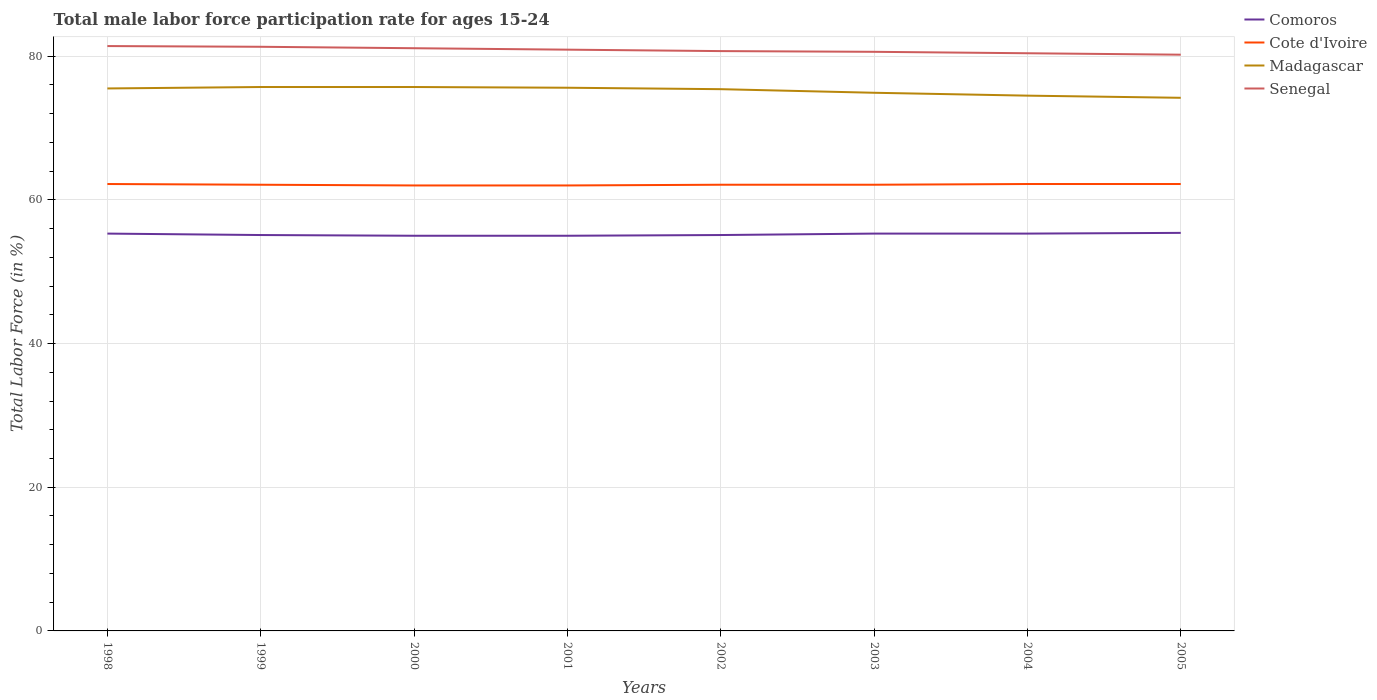Does the line corresponding to Cote d'Ivoire intersect with the line corresponding to Senegal?
Keep it short and to the point. No. Is the number of lines equal to the number of legend labels?
Ensure brevity in your answer.  Yes. Across all years, what is the maximum male labor force participation rate in Senegal?
Offer a terse response. 80.2. What is the total male labor force participation rate in Madagascar in the graph?
Give a very brief answer. 1.4. What is the difference between the highest and the second highest male labor force participation rate in Senegal?
Your response must be concise. 1.2. What is the difference between the highest and the lowest male labor force participation rate in Senegal?
Offer a terse response. 4. Is the male labor force participation rate in Cote d'Ivoire strictly greater than the male labor force participation rate in Comoros over the years?
Give a very brief answer. No. How many lines are there?
Keep it short and to the point. 4. How many years are there in the graph?
Give a very brief answer. 8. What is the difference between two consecutive major ticks on the Y-axis?
Your answer should be compact. 20. How many legend labels are there?
Offer a very short reply. 4. What is the title of the graph?
Give a very brief answer. Total male labor force participation rate for ages 15-24. Does "Namibia" appear as one of the legend labels in the graph?
Make the answer very short. No. What is the label or title of the Y-axis?
Offer a terse response. Total Labor Force (in %). What is the Total Labor Force (in %) of Comoros in 1998?
Offer a terse response. 55.3. What is the Total Labor Force (in %) in Cote d'Ivoire in 1998?
Make the answer very short. 62.2. What is the Total Labor Force (in %) in Madagascar in 1998?
Offer a terse response. 75.5. What is the Total Labor Force (in %) in Senegal in 1998?
Provide a succinct answer. 81.4. What is the Total Labor Force (in %) in Comoros in 1999?
Make the answer very short. 55.1. What is the Total Labor Force (in %) in Cote d'Ivoire in 1999?
Your answer should be compact. 62.1. What is the Total Labor Force (in %) in Madagascar in 1999?
Your answer should be very brief. 75.7. What is the Total Labor Force (in %) in Senegal in 1999?
Your response must be concise. 81.3. What is the Total Labor Force (in %) of Comoros in 2000?
Give a very brief answer. 55. What is the Total Labor Force (in %) of Madagascar in 2000?
Ensure brevity in your answer.  75.7. What is the Total Labor Force (in %) in Senegal in 2000?
Offer a terse response. 81.1. What is the Total Labor Force (in %) in Cote d'Ivoire in 2001?
Give a very brief answer. 62. What is the Total Labor Force (in %) of Madagascar in 2001?
Offer a terse response. 75.6. What is the Total Labor Force (in %) in Senegal in 2001?
Provide a succinct answer. 80.9. What is the Total Labor Force (in %) of Comoros in 2002?
Keep it short and to the point. 55.1. What is the Total Labor Force (in %) of Cote d'Ivoire in 2002?
Provide a short and direct response. 62.1. What is the Total Labor Force (in %) of Madagascar in 2002?
Keep it short and to the point. 75.4. What is the Total Labor Force (in %) in Senegal in 2002?
Ensure brevity in your answer.  80.7. What is the Total Labor Force (in %) in Comoros in 2003?
Your answer should be very brief. 55.3. What is the Total Labor Force (in %) in Cote d'Ivoire in 2003?
Provide a short and direct response. 62.1. What is the Total Labor Force (in %) in Madagascar in 2003?
Offer a very short reply. 74.9. What is the Total Labor Force (in %) in Senegal in 2003?
Offer a very short reply. 80.6. What is the Total Labor Force (in %) in Comoros in 2004?
Keep it short and to the point. 55.3. What is the Total Labor Force (in %) in Cote d'Ivoire in 2004?
Give a very brief answer. 62.2. What is the Total Labor Force (in %) of Madagascar in 2004?
Provide a succinct answer. 74.5. What is the Total Labor Force (in %) in Senegal in 2004?
Give a very brief answer. 80.4. What is the Total Labor Force (in %) in Comoros in 2005?
Give a very brief answer. 55.4. What is the Total Labor Force (in %) of Cote d'Ivoire in 2005?
Your answer should be compact. 62.2. What is the Total Labor Force (in %) in Madagascar in 2005?
Your answer should be compact. 74.2. What is the Total Labor Force (in %) of Senegal in 2005?
Provide a succinct answer. 80.2. Across all years, what is the maximum Total Labor Force (in %) of Comoros?
Your response must be concise. 55.4. Across all years, what is the maximum Total Labor Force (in %) in Cote d'Ivoire?
Your answer should be compact. 62.2. Across all years, what is the maximum Total Labor Force (in %) in Madagascar?
Make the answer very short. 75.7. Across all years, what is the maximum Total Labor Force (in %) in Senegal?
Your response must be concise. 81.4. Across all years, what is the minimum Total Labor Force (in %) of Madagascar?
Your answer should be very brief. 74.2. Across all years, what is the minimum Total Labor Force (in %) of Senegal?
Give a very brief answer. 80.2. What is the total Total Labor Force (in %) of Comoros in the graph?
Your response must be concise. 441.5. What is the total Total Labor Force (in %) of Cote d'Ivoire in the graph?
Give a very brief answer. 496.9. What is the total Total Labor Force (in %) in Madagascar in the graph?
Make the answer very short. 601.5. What is the total Total Labor Force (in %) in Senegal in the graph?
Keep it short and to the point. 646.6. What is the difference between the Total Labor Force (in %) in Cote d'Ivoire in 1998 and that in 1999?
Offer a very short reply. 0.1. What is the difference between the Total Labor Force (in %) in Madagascar in 1998 and that in 1999?
Provide a succinct answer. -0.2. What is the difference between the Total Labor Force (in %) in Madagascar in 1998 and that in 2000?
Give a very brief answer. -0.2. What is the difference between the Total Labor Force (in %) of Comoros in 1998 and that in 2001?
Provide a short and direct response. 0.3. What is the difference between the Total Labor Force (in %) in Madagascar in 1998 and that in 2001?
Give a very brief answer. -0.1. What is the difference between the Total Labor Force (in %) in Senegal in 1998 and that in 2001?
Offer a very short reply. 0.5. What is the difference between the Total Labor Force (in %) in Senegal in 1998 and that in 2002?
Provide a short and direct response. 0.7. What is the difference between the Total Labor Force (in %) of Comoros in 1998 and that in 2003?
Keep it short and to the point. 0. What is the difference between the Total Labor Force (in %) of Cote d'Ivoire in 1998 and that in 2003?
Provide a succinct answer. 0.1. What is the difference between the Total Labor Force (in %) of Madagascar in 1998 and that in 2003?
Make the answer very short. 0.6. What is the difference between the Total Labor Force (in %) in Comoros in 1998 and that in 2004?
Make the answer very short. 0. What is the difference between the Total Labor Force (in %) of Madagascar in 1998 and that in 2005?
Your response must be concise. 1.3. What is the difference between the Total Labor Force (in %) in Senegal in 1998 and that in 2005?
Keep it short and to the point. 1.2. What is the difference between the Total Labor Force (in %) in Comoros in 1999 and that in 2000?
Give a very brief answer. 0.1. What is the difference between the Total Labor Force (in %) in Comoros in 1999 and that in 2001?
Your answer should be compact. 0.1. What is the difference between the Total Labor Force (in %) in Comoros in 1999 and that in 2002?
Offer a terse response. 0. What is the difference between the Total Labor Force (in %) in Senegal in 1999 and that in 2002?
Provide a short and direct response. 0.6. What is the difference between the Total Labor Force (in %) of Cote d'Ivoire in 1999 and that in 2003?
Offer a very short reply. 0. What is the difference between the Total Labor Force (in %) of Comoros in 1999 and that in 2004?
Provide a short and direct response. -0.2. What is the difference between the Total Labor Force (in %) in Madagascar in 1999 and that in 2005?
Ensure brevity in your answer.  1.5. What is the difference between the Total Labor Force (in %) in Comoros in 2000 and that in 2001?
Your answer should be very brief. 0. What is the difference between the Total Labor Force (in %) in Cote d'Ivoire in 2000 and that in 2001?
Offer a terse response. 0. What is the difference between the Total Labor Force (in %) in Madagascar in 2000 and that in 2001?
Your answer should be compact. 0.1. What is the difference between the Total Labor Force (in %) in Comoros in 2000 and that in 2002?
Offer a very short reply. -0.1. What is the difference between the Total Labor Force (in %) in Cote d'Ivoire in 2000 and that in 2002?
Make the answer very short. -0.1. What is the difference between the Total Labor Force (in %) in Madagascar in 2000 and that in 2002?
Your response must be concise. 0.3. What is the difference between the Total Labor Force (in %) of Madagascar in 2000 and that in 2003?
Make the answer very short. 0.8. What is the difference between the Total Labor Force (in %) in Cote d'Ivoire in 2000 and that in 2004?
Make the answer very short. -0.2. What is the difference between the Total Labor Force (in %) in Madagascar in 2000 and that in 2004?
Offer a terse response. 1.2. What is the difference between the Total Labor Force (in %) in Cote d'Ivoire in 2000 and that in 2005?
Offer a very short reply. -0.2. What is the difference between the Total Labor Force (in %) of Madagascar in 2001 and that in 2003?
Ensure brevity in your answer.  0.7. What is the difference between the Total Labor Force (in %) in Madagascar in 2001 and that in 2004?
Provide a short and direct response. 1.1. What is the difference between the Total Labor Force (in %) in Comoros in 2001 and that in 2005?
Offer a terse response. -0.4. What is the difference between the Total Labor Force (in %) in Cote d'Ivoire in 2001 and that in 2005?
Ensure brevity in your answer.  -0.2. What is the difference between the Total Labor Force (in %) in Madagascar in 2001 and that in 2005?
Keep it short and to the point. 1.4. What is the difference between the Total Labor Force (in %) in Senegal in 2001 and that in 2005?
Keep it short and to the point. 0.7. What is the difference between the Total Labor Force (in %) in Comoros in 2002 and that in 2003?
Provide a succinct answer. -0.2. What is the difference between the Total Labor Force (in %) of Cote d'Ivoire in 2002 and that in 2003?
Keep it short and to the point. 0. What is the difference between the Total Labor Force (in %) in Madagascar in 2002 and that in 2003?
Your answer should be very brief. 0.5. What is the difference between the Total Labor Force (in %) of Cote d'Ivoire in 2002 and that in 2004?
Give a very brief answer. -0.1. What is the difference between the Total Labor Force (in %) in Madagascar in 2002 and that in 2004?
Make the answer very short. 0.9. What is the difference between the Total Labor Force (in %) in Comoros in 2002 and that in 2005?
Give a very brief answer. -0.3. What is the difference between the Total Labor Force (in %) of Cote d'Ivoire in 2002 and that in 2005?
Provide a succinct answer. -0.1. What is the difference between the Total Labor Force (in %) of Madagascar in 2002 and that in 2005?
Your answer should be very brief. 1.2. What is the difference between the Total Labor Force (in %) in Senegal in 2002 and that in 2005?
Provide a succinct answer. 0.5. What is the difference between the Total Labor Force (in %) of Comoros in 2003 and that in 2004?
Ensure brevity in your answer.  0. What is the difference between the Total Labor Force (in %) in Cote d'Ivoire in 2003 and that in 2004?
Ensure brevity in your answer.  -0.1. What is the difference between the Total Labor Force (in %) in Senegal in 2003 and that in 2004?
Keep it short and to the point. 0.2. What is the difference between the Total Labor Force (in %) in Madagascar in 2003 and that in 2005?
Offer a very short reply. 0.7. What is the difference between the Total Labor Force (in %) in Comoros in 2004 and that in 2005?
Make the answer very short. -0.1. What is the difference between the Total Labor Force (in %) of Comoros in 1998 and the Total Labor Force (in %) of Cote d'Ivoire in 1999?
Ensure brevity in your answer.  -6.8. What is the difference between the Total Labor Force (in %) of Comoros in 1998 and the Total Labor Force (in %) of Madagascar in 1999?
Provide a short and direct response. -20.4. What is the difference between the Total Labor Force (in %) in Cote d'Ivoire in 1998 and the Total Labor Force (in %) in Madagascar in 1999?
Your response must be concise. -13.5. What is the difference between the Total Labor Force (in %) of Cote d'Ivoire in 1998 and the Total Labor Force (in %) of Senegal in 1999?
Your answer should be compact. -19.1. What is the difference between the Total Labor Force (in %) of Madagascar in 1998 and the Total Labor Force (in %) of Senegal in 1999?
Offer a very short reply. -5.8. What is the difference between the Total Labor Force (in %) of Comoros in 1998 and the Total Labor Force (in %) of Madagascar in 2000?
Ensure brevity in your answer.  -20.4. What is the difference between the Total Labor Force (in %) of Comoros in 1998 and the Total Labor Force (in %) of Senegal in 2000?
Your answer should be compact. -25.8. What is the difference between the Total Labor Force (in %) of Cote d'Ivoire in 1998 and the Total Labor Force (in %) of Senegal in 2000?
Ensure brevity in your answer.  -18.9. What is the difference between the Total Labor Force (in %) of Comoros in 1998 and the Total Labor Force (in %) of Madagascar in 2001?
Provide a succinct answer. -20.3. What is the difference between the Total Labor Force (in %) in Comoros in 1998 and the Total Labor Force (in %) in Senegal in 2001?
Your response must be concise. -25.6. What is the difference between the Total Labor Force (in %) of Cote d'Ivoire in 1998 and the Total Labor Force (in %) of Senegal in 2001?
Provide a succinct answer. -18.7. What is the difference between the Total Labor Force (in %) in Madagascar in 1998 and the Total Labor Force (in %) in Senegal in 2001?
Make the answer very short. -5.4. What is the difference between the Total Labor Force (in %) in Comoros in 1998 and the Total Labor Force (in %) in Cote d'Ivoire in 2002?
Your answer should be compact. -6.8. What is the difference between the Total Labor Force (in %) in Comoros in 1998 and the Total Labor Force (in %) in Madagascar in 2002?
Offer a very short reply. -20.1. What is the difference between the Total Labor Force (in %) in Comoros in 1998 and the Total Labor Force (in %) in Senegal in 2002?
Offer a very short reply. -25.4. What is the difference between the Total Labor Force (in %) of Cote d'Ivoire in 1998 and the Total Labor Force (in %) of Senegal in 2002?
Your answer should be compact. -18.5. What is the difference between the Total Labor Force (in %) in Comoros in 1998 and the Total Labor Force (in %) in Madagascar in 2003?
Keep it short and to the point. -19.6. What is the difference between the Total Labor Force (in %) in Comoros in 1998 and the Total Labor Force (in %) in Senegal in 2003?
Offer a very short reply. -25.3. What is the difference between the Total Labor Force (in %) in Cote d'Ivoire in 1998 and the Total Labor Force (in %) in Madagascar in 2003?
Make the answer very short. -12.7. What is the difference between the Total Labor Force (in %) in Cote d'Ivoire in 1998 and the Total Labor Force (in %) in Senegal in 2003?
Your answer should be compact. -18.4. What is the difference between the Total Labor Force (in %) of Comoros in 1998 and the Total Labor Force (in %) of Madagascar in 2004?
Keep it short and to the point. -19.2. What is the difference between the Total Labor Force (in %) of Comoros in 1998 and the Total Labor Force (in %) of Senegal in 2004?
Offer a terse response. -25.1. What is the difference between the Total Labor Force (in %) of Cote d'Ivoire in 1998 and the Total Labor Force (in %) of Senegal in 2004?
Your answer should be very brief. -18.2. What is the difference between the Total Labor Force (in %) in Comoros in 1998 and the Total Labor Force (in %) in Madagascar in 2005?
Offer a terse response. -18.9. What is the difference between the Total Labor Force (in %) in Comoros in 1998 and the Total Labor Force (in %) in Senegal in 2005?
Your answer should be compact. -24.9. What is the difference between the Total Labor Force (in %) in Cote d'Ivoire in 1998 and the Total Labor Force (in %) in Madagascar in 2005?
Keep it short and to the point. -12. What is the difference between the Total Labor Force (in %) of Cote d'Ivoire in 1998 and the Total Labor Force (in %) of Senegal in 2005?
Your answer should be compact. -18. What is the difference between the Total Labor Force (in %) in Comoros in 1999 and the Total Labor Force (in %) in Madagascar in 2000?
Make the answer very short. -20.6. What is the difference between the Total Labor Force (in %) in Comoros in 1999 and the Total Labor Force (in %) in Senegal in 2000?
Make the answer very short. -26. What is the difference between the Total Labor Force (in %) in Cote d'Ivoire in 1999 and the Total Labor Force (in %) in Senegal in 2000?
Make the answer very short. -19. What is the difference between the Total Labor Force (in %) of Madagascar in 1999 and the Total Labor Force (in %) of Senegal in 2000?
Provide a succinct answer. -5.4. What is the difference between the Total Labor Force (in %) of Comoros in 1999 and the Total Labor Force (in %) of Madagascar in 2001?
Give a very brief answer. -20.5. What is the difference between the Total Labor Force (in %) in Comoros in 1999 and the Total Labor Force (in %) in Senegal in 2001?
Make the answer very short. -25.8. What is the difference between the Total Labor Force (in %) in Cote d'Ivoire in 1999 and the Total Labor Force (in %) in Madagascar in 2001?
Ensure brevity in your answer.  -13.5. What is the difference between the Total Labor Force (in %) in Cote d'Ivoire in 1999 and the Total Labor Force (in %) in Senegal in 2001?
Your answer should be very brief. -18.8. What is the difference between the Total Labor Force (in %) in Madagascar in 1999 and the Total Labor Force (in %) in Senegal in 2001?
Offer a very short reply. -5.2. What is the difference between the Total Labor Force (in %) of Comoros in 1999 and the Total Labor Force (in %) of Madagascar in 2002?
Make the answer very short. -20.3. What is the difference between the Total Labor Force (in %) in Comoros in 1999 and the Total Labor Force (in %) in Senegal in 2002?
Provide a short and direct response. -25.6. What is the difference between the Total Labor Force (in %) in Cote d'Ivoire in 1999 and the Total Labor Force (in %) in Senegal in 2002?
Give a very brief answer. -18.6. What is the difference between the Total Labor Force (in %) in Comoros in 1999 and the Total Labor Force (in %) in Madagascar in 2003?
Ensure brevity in your answer.  -19.8. What is the difference between the Total Labor Force (in %) in Comoros in 1999 and the Total Labor Force (in %) in Senegal in 2003?
Your answer should be very brief. -25.5. What is the difference between the Total Labor Force (in %) in Cote d'Ivoire in 1999 and the Total Labor Force (in %) in Madagascar in 2003?
Provide a succinct answer. -12.8. What is the difference between the Total Labor Force (in %) in Cote d'Ivoire in 1999 and the Total Labor Force (in %) in Senegal in 2003?
Your response must be concise. -18.5. What is the difference between the Total Labor Force (in %) of Madagascar in 1999 and the Total Labor Force (in %) of Senegal in 2003?
Ensure brevity in your answer.  -4.9. What is the difference between the Total Labor Force (in %) of Comoros in 1999 and the Total Labor Force (in %) of Madagascar in 2004?
Your answer should be very brief. -19.4. What is the difference between the Total Labor Force (in %) of Comoros in 1999 and the Total Labor Force (in %) of Senegal in 2004?
Make the answer very short. -25.3. What is the difference between the Total Labor Force (in %) in Cote d'Ivoire in 1999 and the Total Labor Force (in %) in Senegal in 2004?
Give a very brief answer. -18.3. What is the difference between the Total Labor Force (in %) in Madagascar in 1999 and the Total Labor Force (in %) in Senegal in 2004?
Your answer should be very brief. -4.7. What is the difference between the Total Labor Force (in %) of Comoros in 1999 and the Total Labor Force (in %) of Cote d'Ivoire in 2005?
Make the answer very short. -7.1. What is the difference between the Total Labor Force (in %) in Comoros in 1999 and the Total Labor Force (in %) in Madagascar in 2005?
Give a very brief answer. -19.1. What is the difference between the Total Labor Force (in %) of Comoros in 1999 and the Total Labor Force (in %) of Senegal in 2005?
Your response must be concise. -25.1. What is the difference between the Total Labor Force (in %) in Cote d'Ivoire in 1999 and the Total Labor Force (in %) in Senegal in 2005?
Make the answer very short. -18.1. What is the difference between the Total Labor Force (in %) in Madagascar in 1999 and the Total Labor Force (in %) in Senegal in 2005?
Your answer should be very brief. -4.5. What is the difference between the Total Labor Force (in %) of Comoros in 2000 and the Total Labor Force (in %) of Cote d'Ivoire in 2001?
Ensure brevity in your answer.  -7. What is the difference between the Total Labor Force (in %) in Comoros in 2000 and the Total Labor Force (in %) in Madagascar in 2001?
Your response must be concise. -20.6. What is the difference between the Total Labor Force (in %) in Comoros in 2000 and the Total Labor Force (in %) in Senegal in 2001?
Provide a short and direct response. -25.9. What is the difference between the Total Labor Force (in %) of Cote d'Ivoire in 2000 and the Total Labor Force (in %) of Madagascar in 2001?
Provide a succinct answer. -13.6. What is the difference between the Total Labor Force (in %) of Cote d'Ivoire in 2000 and the Total Labor Force (in %) of Senegal in 2001?
Your response must be concise. -18.9. What is the difference between the Total Labor Force (in %) in Madagascar in 2000 and the Total Labor Force (in %) in Senegal in 2001?
Your answer should be very brief. -5.2. What is the difference between the Total Labor Force (in %) in Comoros in 2000 and the Total Labor Force (in %) in Cote d'Ivoire in 2002?
Provide a succinct answer. -7.1. What is the difference between the Total Labor Force (in %) of Comoros in 2000 and the Total Labor Force (in %) of Madagascar in 2002?
Your answer should be compact. -20.4. What is the difference between the Total Labor Force (in %) in Comoros in 2000 and the Total Labor Force (in %) in Senegal in 2002?
Offer a terse response. -25.7. What is the difference between the Total Labor Force (in %) of Cote d'Ivoire in 2000 and the Total Labor Force (in %) of Senegal in 2002?
Offer a terse response. -18.7. What is the difference between the Total Labor Force (in %) in Comoros in 2000 and the Total Labor Force (in %) in Cote d'Ivoire in 2003?
Keep it short and to the point. -7.1. What is the difference between the Total Labor Force (in %) in Comoros in 2000 and the Total Labor Force (in %) in Madagascar in 2003?
Keep it short and to the point. -19.9. What is the difference between the Total Labor Force (in %) of Comoros in 2000 and the Total Labor Force (in %) of Senegal in 2003?
Provide a succinct answer. -25.6. What is the difference between the Total Labor Force (in %) of Cote d'Ivoire in 2000 and the Total Labor Force (in %) of Madagascar in 2003?
Offer a terse response. -12.9. What is the difference between the Total Labor Force (in %) of Cote d'Ivoire in 2000 and the Total Labor Force (in %) of Senegal in 2003?
Make the answer very short. -18.6. What is the difference between the Total Labor Force (in %) of Madagascar in 2000 and the Total Labor Force (in %) of Senegal in 2003?
Make the answer very short. -4.9. What is the difference between the Total Labor Force (in %) of Comoros in 2000 and the Total Labor Force (in %) of Madagascar in 2004?
Provide a short and direct response. -19.5. What is the difference between the Total Labor Force (in %) in Comoros in 2000 and the Total Labor Force (in %) in Senegal in 2004?
Offer a very short reply. -25.4. What is the difference between the Total Labor Force (in %) in Cote d'Ivoire in 2000 and the Total Labor Force (in %) in Madagascar in 2004?
Offer a terse response. -12.5. What is the difference between the Total Labor Force (in %) of Cote d'Ivoire in 2000 and the Total Labor Force (in %) of Senegal in 2004?
Make the answer very short. -18.4. What is the difference between the Total Labor Force (in %) of Madagascar in 2000 and the Total Labor Force (in %) of Senegal in 2004?
Keep it short and to the point. -4.7. What is the difference between the Total Labor Force (in %) of Comoros in 2000 and the Total Labor Force (in %) of Madagascar in 2005?
Your answer should be very brief. -19.2. What is the difference between the Total Labor Force (in %) of Comoros in 2000 and the Total Labor Force (in %) of Senegal in 2005?
Make the answer very short. -25.2. What is the difference between the Total Labor Force (in %) of Cote d'Ivoire in 2000 and the Total Labor Force (in %) of Senegal in 2005?
Offer a terse response. -18.2. What is the difference between the Total Labor Force (in %) in Comoros in 2001 and the Total Labor Force (in %) in Cote d'Ivoire in 2002?
Provide a short and direct response. -7.1. What is the difference between the Total Labor Force (in %) in Comoros in 2001 and the Total Labor Force (in %) in Madagascar in 2002?
Your answer should be compact. -20.4. What is the difference between the Total Labor Force (in %) in Comoros in 2001 and the Total Labor Force (in %) in Senegal in 2002?
Keep it short and to the point. -25.7. What is the difference between the Total Labor Force (in %) of Cote d'Ivoire in 2001 and the Total Labor Force (in %) of Madagascar in 2002?
Ensure brevity in your answer.  -13.4. What is the difference between the Total Labor Force (in %) in Cote d'Ivoire in 2001 and the Total Labor Force (in %) in Senegal in 2002?
Offer a terse response. -18.7. What is the difference between the Total Labor Force (in %) of Madagascar in 2001 and the Total Labor Force (in %) of Senegal in 2002?
Offer a very short reply. -5.1. What is the difference between the Total Labor Force (in %) of Comoros in 2001 and the Total Labor Force (in %) of Madagascar in 2003?
Provide a short and direct response. -19.9. What is the difference between the Total Labor Force (in %) of Comoros in 2001 and the Total Labor Force (in %) of Senegal in 2003?
Offer a terse response. -25.6. What is the difference between the Total Labor Force (in %) in Cote d'Ivoire in 2001 and the Total Labor Force (in %) in Senegal in 2003?
Offer a terse response. -18.6. What is the difference between the Total Labor Force (in %) of Comoros in 2001 and the Total Labor Force (in %) of Madagascar in 2004?
Ensure brevity in your answer.  -19.5. What is the difference between the Total Labor Force (in %) in Comoros in 2001 and the Total Labor Force (in %) in Senegal in 2004?
Offer a very short reply. -25.4. What is the difference between the Total Labor Force (in %) of Cote d'Ivoire in 2001 and the Total Labor Force (in %) of Senegal in 2004?
Give a very brief answer. -18.4. What is the difference between the Total Labor Force (in %) in Madagascar in 2001 and the Total Labor Force (in %) in Senegal in 2004?
Provide a succinct answer. -4.8. What is the difference between the Total Labor Force (in %) in Comoros in 2001 and the Total Labor Force (in %) in Cote d'Ivoire in 2005?
Offer a very short reply. -7.2. What is the difference between the Total Labor Force (in %) in Comoros in 2001 and the Total Labor Force (in %) in Madagascar in 2005?
Your answer should be compact. -19.2. What is the difference between the Total Labor Force (in %) in Comoros in 2001 and the Total Labor Force (in %) in Senegal in 2005?
Keep it short and to the point. -25.2. What is the difference between the Total Labor Force (in %) of Cote d'Ivoire in 2001 and the Total Labor Force (in %) of Senegal in 2005?
Keep it short and to the point. -18.2. What is the difference between the Total Labor Force (in %) of Comoros in 2002 and the Total Labor Force (in %) of Cote d'Ivoire in 2003?
Provide a succinct answer. -7. What is the difference between the Total Labor Force (in %) of Comoros in 2002 and the Total Labor Force (in %) of Madagascar in 2003?
Provide a short and direct response. -19.8. What is the difference between the Total Labor Force (in %) in Comoros in 2002 and the Total Labor Force (in %) in Senegal in 2003?
Your answer should be very brief. -25.5. What is the difference between the Total Labor Force (in %) in Cote d'Ivoire in 2002 and the Total Labor Force (in %) in Madagascar in 2003?
Offer a very short reply. -12.8. What is the difference between the Total Labor Force (in %) of Cote d'Ivoire in 2002 and the Total Labor Force (in %) of Senegal in 2003?
Keep it short and to the point. -18.5. What is the difference between the Total Labor Force (in %) of Madagascar in 2002 and the Total Labor Force (in %) of Senegal in 2003?
Your response must be concise. -5.2. What is the difference between the Total Labor Force (in %) of Comoros in 2002 and the Total Labor Force (in %) of Cote d'Ivoire in 2004?
Your answer should be very brief. -7.1. What is the difference between the Total Labor Force (in %) of Comoros in 2002 and the Total Labor Force (in %) of Madagascar in 2004?
Provide a succinct answer. -19.4. What is the difference between the Total Labor Force (in %) in Comoros in 2002 and the Total Labor Force (in %) in Senegal in 2004?
Keep it short and to the point. -25.3. What is the difference between the Total Labor Force (in %) of Cote d'Ivoire in 2002 and the Total Labor Force (in %) of Senegal in 2004?
Your answer should be very brief. -18.3. What is the difference between the Total Labor Force (in %) of Madagascar in 2002 and the Total Labor Force (in %) of Senegal in 2004?
Ensure brevity in your answer.  -5. What is the difference between the Total Labor Force (in %) in Comoros in 2002 and the Total Labor Force (in %) in Cote d'Ivoire in 2005?
Your answer should be compact. -7.1. What is the difference between the Total Labor Force (in %) in Comoros in 2002 and the Total Labor Force (in %) in Madagascar in 2005?
Offer a terse response. -19.1. What is the difference between the Total Labor Force (in %) in Comoros in 2002 and the Total Labor Force (in %) in Senegal in 2005?
Provide a short and direct response. -25.1. What is the difference between the Total Labor Force (in %) of Cote d'Ivoire in 2002 and the Total Labor Force (in %) of Madagascar in 2005?
Keep it short and to the point. -12.1. What is the difference between the Total Labor Force (in %) in Cote d'Ivoire in 2002 and the Total Labor Force (in %) in Senegal in 2005?
Your answer should be very brief. -18.1. What is the difference between the Total Labor Force (in %) in Madagascar in 2002 and the Total Labor Force (in %) in Senegal in 2005?
Your answer should be compact. -4.8. What is the difference between the Total Labor Force (in %) in Comoros in 2003 and the Total Labor Force (in %) in Madagascar in 2004?
Make the answer very short. -19.2. What is the difference between the Total Labor Force (in %) of Comoros in 2003 and the Total Labor Force (in %) of Senegal in 2004?
Your answer should be very brief. -25.1. What is the difference between the Total Labor Force (in %) in Cote d'Ivoire in 2003 and the Total Labor Force (in %) in Senegal in 2004?
Provide a succinct answer. -18.3. What is the difference between the Total Labor Force (in %) in Comoros in 2003 and the Total Labor Force (in %) in Madagascar in 2005?
Ensure brevity in your answer.  -18.9. What is the difference between the Total Labor Force (in %) of Comoros in 2003 and the Total Labor Force (in %) of Senegal in 2005?
Ensure brevity in your answer.  -24.9. What is the difference between the Total Labor Force (in %) in Cote d'Ivoire in 2003 and the Total Labor Force (in %) in Senegal in 2005?
Keep it short and to the point. -18.1. What is the difference between the Total Labor Force (in %) of Comoros in 2004 and the Total Labor Force (in %) of Cote d'Ivoire in 2005?
Keep it short and to the point. -6.9. What is the difference between the Total Labor Force (in %) in Comoros in 2004 and the Total Labor Force (in %) in Madagascar in 2005?
Offer a terse response. -18.9. What is the difference between the Total Labor Force (in %) of Comoros in 2004 and the Total Labor Force (in %) of Senegal in 2005?
Provide a succinct answer. -24.9. What is the difference between the Total Labor Force (in %) of Cote d'Ivoire in 2004 and the Total Labor Force (in %) of Senegal in 2005?
Offer a terse response. -18. What is the difference between the Total Labor Force (in %) in Madagascar in 2004 and the Total Labor Force (in %) in Senegal in 2005?
Make the answer very short. -5.7. What is the average Total Labor Force (in %) in Comoros per year?
Offer a terse response. 55.19. What is the average Total Labor Force (in %) of Cote d'Ivoire per year?
Provide a succinct answer. 62.11. What is the average Total Labor Force (in %) in Madagascar per year?
Your answer should be very brief. 75.19. What is the average Total Labor Force (in %) of Senegal per year?
Keep it short and to the point. 80.83. In the year 1998, what is the difference between the Total Labor Force (in %) of Comoros and Total Labor Force (in %) of Cote d'Ivoire?
Offer a very short reply. -6.9. In the year 1998, what is the difference between the Total Labor Force (in %) of Comoros and Total Labor Force (in %) of Madagascar?
Your answer should be compact. -20.2. In the year 1998, what is the difference between the Total Labor Force (in %) of Comoros and Total Labor Force (in %) of Senegal?
Your response must be concise. -26.1. In the year 1998, what is the difference between the Total Labor Force (in %) in Cote d'Ivoire and Total Labor Force (in %) in Senegal?
Provide a succinct answer. -19.2. In the year 1998, what is the difference between the Total Labor Force (in %) in Madagascar and Total Labor Force (in %) in Senegal?
Give a very brief answer. -5.9. In the year 1999, what is the difference between the Total Labor Force (in %) of Comoros and Total Labor Force (in %) of Madagascar?
Your response must be concise. -20.6. In the year 1999, what is the difference between the Total Labor Force (in %) of Comoros and Total Labor Force (in %) of Senegal?
Provide a short and direct response. -26.2. In the year 1999, what is the difference between the Total Labor Force (in %) in Cote d'Ivoire and Total Labor Force (in %) in Senegal?
Your answer should be compact. -19.2. In the year 1999, what is the difference between the Total Labor Force (in %) of Madagascar and Total Labor Force (in %) of Senegal?
Your answer should be very brief. -5.6. In the year 2000, what is the difference between the Total Labor Force (in %) of Comoros and Total Labor Force (in %) of Madagascar?
Provide a short and direct response. -20.7. In the year 2000, what is the difference between the Total Labor Force (in %) of Comoros and Total Labor Force (in %) of Senegal?
Provide a succinct answer. -26.1. In the year 2000, what is the difference between the Total Labor Force (in %) of Cote d'Ivoire and Total Labor Force (in %) of Madagascar?
Keep it short and to the point. -13.7. In the year 2000, what is the difference between the Total Labor Force (in %) of Cote d'Ivoire and Total Labor Force (in %) of Senegal?
Provide a succinct answer. -19.1. In the year 2000, what is the difference between the Total Labor Force (in %) of Madagascar and Total Labor Force (in %) of Senegal?
Your response must be concise. -5.4. In the year 2001, what is the difference between the Total Labor Force (in %) in Comoros and Total Labor Force (in %) in Cote d'Ivoire?
Keep it short and to the point. -7. In the year 2001, what is the difference between the Total Labor Force (in %) in Comoros and Total Labor Force (in %) in Madagascar?
Give a very brief answer. -20.6. In the year 2001, what is the difference between the Total Labor Force (in %) in Comoros and Total Labor Force (in %) in Senegal?
Ensure brevity in your answer.  -25.9. In the year 2001, what is the difference between the Total Labor Force (in %) of Cote d'Ivoire and Total Labor Force (in %) of Madagascar?
Offer a very short reply. -13.6. In the year 2001, what is the difference between the Total Labor Force (in %) of Cote d'Ivoire and Total Labor Force (in %) of Senegal?
Provide a short and direct response. -18.9. In the year 2001, what is the difference between the Total Labor Force (in %) of Madagascar and Total Labor Force (in %) of Senegal?
Offer a very short reply. -5.3. In the year 2002, what is the difference between the Total Labor Force (in %) in Comoros and Total Labor Force (in %) in Madagascar?
Provide a short and direct response. -20.3. In the year 2002, what is the difference between the Total Labor Force (in %) in Comoros and Total Labor Force (in %) in Senegal?
Offer a terse response. -25.6. In the year 2002, what is the difference between the Total Labor Force (in %) in Cote d'Ivoire and Total Labor Force (in %) in Senegal?
Give a very brief answer. -18.6. In the year 2003, what is the difference between the Total Labor Force (in %) of Comoros and Total Labor Force (in %) of Cote d'Ivoire?
Ensure brevity in your answer.  -6.8. In the year 2003, what is the difference between the Total Labor Force (in %) in Comoros and Total Labor Force (in %) in Madagascar?
Give a very brief answer. -19.6. In the year 2003, what is the difference between the Total Labor Force (in %) of Comoros and Total Labor Force (in %) of Senegal?
Offer a very short reply. -25.3. In the year 2003, what is the difference between the Total Labor Force (in %) in Cote d'Ivoire and Total Labor Force (in %) in Madagascar?
Keep it short and to the point. -12.8. In the year 2003, what is the difference between the Total Labor Force (in %) in Cote d'Ivoire and Total Labor Force (in %) in Senegal?
Make the answer very short. -18.5. In the year 2003, what is the difference between the Total Labor Force (in %) in Madagascar and Total Labor Force (in %) in Senegal?
Keep it short and to the point. -5.7. In the year 2004, what is the difference between the Total Labor Force (in %) in Comoros and Total Labor Force (in %) in Cote d'Ivoire?
Your response must be concise. -6.9. In the year 2004, what is the difference between the Total Labor Force (in %) in Comoros and Total Labor Force (in %) in Madagascar?
Make the answer very short. -19.2. In the year 2004, what is the difference between the Total Labor Force (in %) in Comoros and Total Labor Force (in %) in Senegal?
Offer a terse response. -25.1. In the year 2004, what is the difference between the Total Labor Force (in %) of Cote d'Ivoire and Total Labor Force (in %) of Senegal?
Provide a succinct answer. -18.2. In the year 2005, what is the difference between the Total Labor Force (in %) in Comoros and Total Labor Force (in %) in Madagascar?
Ensure brevity in your answer.  -18.8. In the year 2005, what is the difference between the Total Labor Force (in %) of Comoros and Total Labor Force (in %) of Senegal?
Keep it short and to the point. -24.8. In the year 2005, what is the difference between the Total Labor Force (in %) of Cote d'Ivoire and Total Labor Force (in %) of Madagascar?
Provide a succinct answer. -12. In the year 2005, what is the difference between the Total Labor Force (in %) in Cote d'Ivoire and Total Labor Force (in %) in Senegal?
Provide a succinct answer. -18. What is the ratio of the Total Labor Force (in %) of Comoros in 1998 to that in 1999?
Provide a short and direct response. 1. What is the ratio of the Total Labor Force (in %) in Madagascar in 1998 to that in 1999?
Offer a very short reply. 1. What is the ratio of the Total Labor Force (in %) in Senegal in 1998 to that in 1999?
Your answer should be compact. 1. What is the ratio of the Total Labor Force (in %) in Cote d'Ivoire in 1998 to that in 2000?
Offer a terse response. 1. What is the ratio of the Total Labor Force (in %) in Madagascar in 1998 to that in 2000?
Provide a succinct answer. 1. What is the ratio of the Total Labor Force (in %) in Senegal in 1998 to that in 2000?
Provide a short and direct response. 1. What is the ratio of the Total Labor Force (in %) of Comoros in 1998 to that in 2001?
Offer a very short reply. 1.01. What is the ratio of the Total Labor Force (in %) in Comoros in 1998 to that in 2002?
Your answer should be very brief. 1. What is the ratio of the Total Labor Force (in %) of Madagascar in 1998 to that in 2002?
Provide a succinct answer. 1. What is the ratio of the Total Labor Force (in %) of Senegal in 1998 to that in 2002?
Your answer should be very brief. 1.01. What is the ratio of the Total Labor Force (in %) of Senegal in 1998 to that in 2003?
Keep it short and to the point. 1.01. What is the ratio of the Total Labor Force (in %) of Madagascar in 1998 to that in 2004?
Provide a succinct answer. 1.01. What is the ratio of the Total Labor Force (in %) in Senegal in 1998 to that in 2004?
Your response must be concise. 1.01. What is the ratio of the Total Labor Force (in %) of Madagascar in 1998 to that in 2005?
Provide a short and direct response. 1.02. What is the ratio of the Total Labor Force (in %) of Senegal in 1998 to that in 2005?
Give a very brief answer. 1.01. What is the ratio of the Total Labor Force (in %) of Madagascar in 1999 to that in 2000?
Offer a very short reply. 1. What is the ratio of the Total Labor Force (in %) in Senegal in 1999 to that in 2000?
Your answer should be very brief. 1. What is the ratio of the Total Labor Force (in %) of Madagascar in 1999 to that in 2001?
Offer a terse response. 1. What is the ratio of the Total Labor Force (in %) of Senegal in 1999 to that in 2001?
Your response must be concise. 1. What is the ratio of the Total Labor Force (in %) of Cote d'Ivoire in 1999 to that in 2002?
Offer a very short reply. 1. What is the ratio of the Total Labor Force (in %) of Madagascar in 1999 to that in 2002?
Provide a short and direct response. 1. What is the ratio of the Total Labor Force (in %) of Senegal in 1999 to that in 2002?
Provide a succinct answer. 1.01. What is the ratio of the Total Labor Force (in %) of Cote d'Ivoire in 1999 to that in 2003?
Make the answer very short. 1. What is the ratio of the Total Labor Force (in %) of Madagascar in 1999 to that in 2003?
Offer a terse response. 1.01. What is the ratio of the Total Labor Force (in %) of Senegal in 1999 to that in 2003?
Offer a very short reply. 1.01. What is the ratio of the Total Labor Force (in %) of Comoros in 1999 to that in 2004?
Offer a very short reply. 1. What is the ratio of the Total Labor Force (in %) of Cote d'Ivoire in 1999 to that in 2004?
Provide a succinct answer. 1. What is the ratio of the Total Labor Force (in %) of Madagascar in 1999 to that in 2004?
Offer a terse response. 1.02. What is the ratio of the Total Labor Force (in %) of Senegal in 1999 to that in 2004?
Offer a terse response. 1.01. What is the ratio of the Total Labor Force (in %) in Comoros in 1999 to that in 2005?
Your response must be concise. 0.99. What is the ratio of the Total Labor Force (in %) of Madagascar in 1999 to that in 2005?
Your answer should be compact. 1.02. What is the ratio of the Total Labor Force (in %) in Senegal in 1999 to that in 2005?
Give a very brief answer. 1.01. What is the ratio of the Total Labor Force (in %) in Cote d'Ivoire in 2000 to that in 2001?
Provide a short and direct response. 1. What is the ratio of the Total Labor Force (in %) of Comoros in 2000 to that in 2002?
Your answer should be very brief. 1. What is the ratio of the Total Labor Force (in %) in Cote d'Ivoire in 2000 to that in 2002?
Provide a short and direct response. 1. What is the ratio of the Total Labor Force (in %) of Senegal in 2000 to that in 2002?
Make the answer very short. 1. What is the ratio of the Total Labor Force (in %) in Cote d'Ivoire in 2000 to that in 2003?
Your answer should be compact. 1. What is the ratio of the Total Labor Force (in %) of Madagascar in 2000 to that in 2003?
Provide a succinct answer. 1.01. What is the ratio of the Total Labor Force (in %) of Comoros in 2000 to that in 2004?
Your answer should be very brief. 0.99. What is the ratio of the Total Labor Force (in %) in Madagascar in 2000 to that in 2004?
Provide a succinct answer. 1.02. What is the ratio of the Total Labor Force (in %) of Senegal in 2000 to that in 2004?
Offer a very short reply. 1.01. What is the ratio of the Total Labor Force (in %) of Madagascar in 2000 to that in 2005?
Provide a succinct answer. 1.02. What is the ratio of the Total Labor Force (in %) of Senegal in 2000 to that in 2005?
Your answer should be very brief. 1.01. What is the ratio of the Total Labor Force (in %) in Comoros in 2001 to that in 2002?
Provide a short and direct response. 1. What is the ratio of the Total Labor Force (in %) in Cote d'Ivoire in 2001 to that in 2002?
Your answer should be compact. 1. What is the ratio of the Total Labor Force (in %) of Madagascar in 2001 to that in 2002?
Offer a terse response. 1. What is the ratio of the Total Labor Force (in %) of Senegal in 2001 to that in 2002?
Give a very brief answer. 1. What is the ratio of the Total Labor Force (in %) in Cote d'Ivoire in 2001 to that in 2003?
Your answer should be very brief. 1. What is the ratio of the Total Labor Force (in %) of Madagascar in 2001 to that in 2003?
Your answer should be very brief. 1.01. What is the ratio of the Total Labor Force (in %) in Madagascar in 2001 to that in 2004?
Offer a terse response. 1.01. What is the ratio of the Total Labor Force (in %) of Senegal in 2001 to that in 2004?
Provide a short and direct response. 1.01. What is the ratio of the Total Labor Force (in %) in Cote d'Ivoire in 2001 to that in 2005?
Ensure brevity in your answer.  1. What is the ratio of the Total Labor Force (in %) in Madagascar in 2001 to that in 2005?
Offer a very short reply. 1.02. What is the ratio of the Total Labor Force (in %) in Senegal in 2001 to that in 2005?
Offer a terse response. 1.01. What is the ratio of the Total Labor Force (in %) in Comoros in 2002 to that in 2004?
Your answer should be compact. 1. What is the ratio of the Total Labor Force (in %) of Madagascar in 2002 to that in 2004?
Make the answer very short. 1.01. What is the ratio of the Total Labor Force (in %) in Comoros in 2002 to that in 2005?
Offer a very short reply. 0.99. What is the ratio of the Total Labor Force (in %) of Madagascar in 2002 to that in 2005?
Your answer should be compact. 1.02. What is the ratio of the Total Labor Force (in %) of Senegal in 2002 to that in 2005?
Keep it short and to the point. 1.01. What is the ratio of the Total Labor Force (in %) in Comoros in 2003 to that in 2004?
Provide a succinct answer. 1. What is the ratio of the Total Labor Force (in %) of Madagascar in 2003 to that in 2004?
Your answer should be compact. 1.01. What is the ratio of the Total Labor Force (in %) in Senegal in 2003 to that in 2004?
Your answer should be compact. 1. What is the ratio of the Total Labor Force (in %) of Cote d'Ivoire in 2003 to that in 2005?
Ensure brevity in your answer.  1. What is the ratio of the Total Labor Force (in %) of Madagascar in 2003 to that in 2005?
Your answer should be compact. 1.01. What is the ratio of the Total Labor Force (in %) of Comoros in 2004 to that in 2005?
Ensure brevity in your answer.  1. What is the ratio of the Total Labor Force (in %) of Senegal in 2004 to that in 2005?
Ensure brevity in your answer.  1. What is the difference between the highest and the second highest Total Labor Force (in %) in Comoros?
Make the answer very short. 0.1. What is the difference between the highest and the second highest Total Labor Force (in %) of Madagascar?
Offer a very short reply. 0. What is the difference between the highest and the lowest Total Labor Force (in %) in Comoros?
Your response must be concise. 0.4. What is the difference between the highest and the lowest Total Labor Force (in %) in Cote d'Ivoire?
Give a very brief answer. 0.2. What is the difference between the highest and the lowest Total Labor Force (in %) in Senegal?
Your answer should be compact. 1.2. 